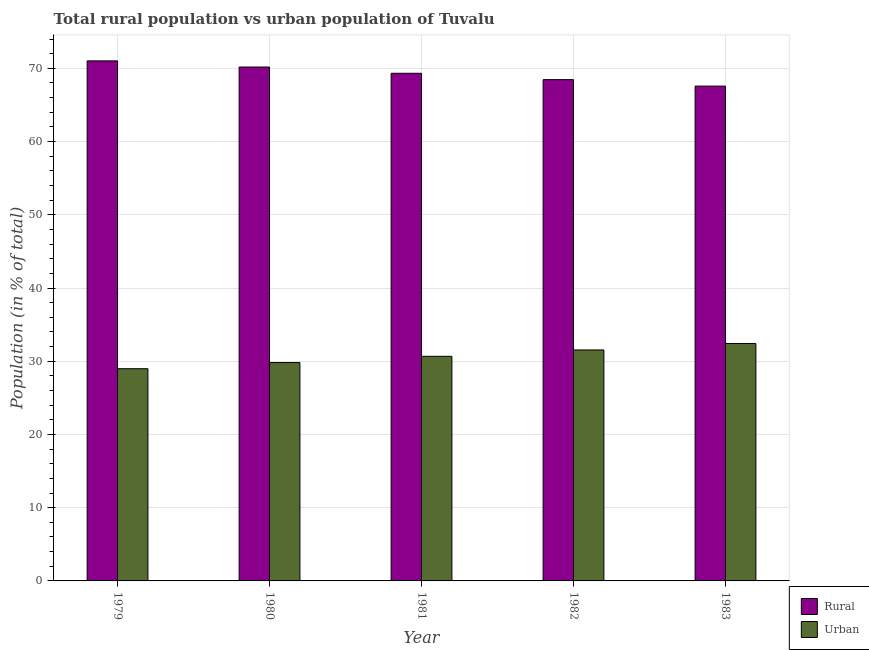How many different coloured bars are there?
Your response must be concise. 2. Are the number of bars on each tick of the X-axis equal?
Keep it short and to the point. Yes. How many bars are there on the 4th tick from the left?
Offer a very short reply. 2. In how many cases, is the number of bars for a given year not equal to the number of legend labels?
Keep it short and to the point. 0. What is the rural population in 1979?
Provide a short and direct response. 71.02. Across all years, what is the maximum rural population?
Make the answer very short. 71.02. Across all years, what is the minimum rural population?
Offer a very short reply. 67.58. In which year was the rural population maximum?
Your response must be concise. 1979. In which year was the urban population minimum?
Give a very brief answer. 1979. What is the total rural population in the graph?
Offer a very short reply. 346.55. What is the difference between the urban population in 1981 and that in 1983?
Your answer should be compact. -1.75. What is the difference between the rural population in 1979 and the urban population in 1982?
Provide a succinct answer. 2.56. What is the average rural population per year?
Make the answer very short. 69.31. In the year 1980, what is the difference between the urban population and rural population?
Make the answer very short. 0. What is the ratio of the rural population in 1981 to that in 1983?
Offer a very short reply. 1.03. Is the urban population in 1980 less than that in 1981?
Offer a very short reply. Yes. What is the difference between the highest and the second highest urban population?
Ensure brevity in your answer.  0.88. What is the difference between the highest and the lowest urban population?
Your response must be concise. 3.44. Is the sum of the urban population in 1980 and 1982 greater than the maximum rural population across all years?
Your answer should be compact. Yes. What does the 2nd bar from the left in 1979 represents?
Keep it short and to the point. Urban. What does the 2nd bar from the right in 1979 represents?
Offer a terse response. Rural. How many bars are there?
Provide a short and direct response. 10. What is the difference between two consecutive major ticks on the Y-axis?
Offer a terse response. 10. Are the values on the major ticks of Y-axis written in scientific E-notation?
Offer a terse response. No. Does the graph contain any zero values?
Your answer should be compact. No. Does the graph contain grids?
Keep it short and to the point. Yes. Where does the legend appear in the graph?
Ensure brevity in your answer.  Bottom right. How many legend labels are there?
Provide a short and direct response. 2. How are the legend labels stacked?
Your answer should be very brief. Vertical. What is the title of the graph?
Your answer should be very brief. Total rural population vs urban population of Tuvalu. What is the label or title of the X-axis?
Your response must be concise. Year. What is the label or title of the Y-axis?
Make the answer very short. Population (in % of total). What is the Population (in % of total) in Rural in 1979?
Your answer should be very brief. 71.02. What is the Population (in % of total) of Urban in 1979?
Ensure brevity in your answer.  28.98. What is the Population (in % of total) in Rural in 1980?
Provide a succinct answer. 70.18. What is the Population (in % of total) of Urban in 1980?
Offer a very short reply. 29.82. What is the Population (in % of total) of Rural in 1981?
Make the answer very short. 69.33. What is the Population (in % of total) of Urban in 1981?
Your response must be concise. 30.68. What is the Population (in % of total) of Rural in 1982?
Make the answer very short. 68.46. What is the Population (in % of total) of Urban in 1982?
Provide a short and direct response. 31.54. What is the Population (in % of total) of Rural in 1983?
Make the answer very short. 67.58. What is the Population (in % of total) of Urban in 1983?
Offer a terse response. 32.42. Across all years, what is the maximum Population (in % of total) in Rural?
Make the answer very short. 71.02. Across all years, what is the maximum Population (in % of total) of Urban?
Provide a succinct answer. 32.42. Across all years, what is the minimum Population (in % of total) in Rural?
Your answer should be compact. 67.58. Across all years, what is the minimum Population (in % of total) of Urban?
Your answer should be very brief. 28.98. What is the total Population (in % of total) of Rural in the graph?
Offer a very short reply. 346.55. What is the total Population (in % of total) of Urban in the graph?
Provide a succinct answer. 153.45. What is the difference between the Population (in % of total) of Rural in 1979 and that in 1980?
Provide a short and direct response. 0.84. What is the difference between the Population (in % of total) of Urban in 1979 and that in 1980?
Offer a terse response. -0.84. What is the difference between the Population (in % of total) in Rural in 1979 and that in 1981?
Give a very brief answer. 1.7. What is the difference between the Population (in % of total) of Urban in 1979 and that in 1981?
Keep it short and to the point. -1.7. What is the difference between the Population (in % of total) of Rural in 1979 and that in 1982?
Keep it short and to the point. 2.56. What is the difference between the Population (in % of total) of Urban in 1979 and that in 1982?
Give a very brief answer. -2.56. What is the difference between the Population (in % of total) of Rural in 1979 and that in 1983?
Make the answer very short. 3.44. What is the difference between the Population (in % of total) in Urban in 1979 and that in 1983?
Your answer should be compact. -3.44. What is the difference between the Population (in % of total) in Rural in 1980 and that in 1981?
Keep it short and to the point. 0.85. What is the difference between the Population (in % of total) of Urban in 1980 and that in 1981?
Your answer should be very brief. -0.85. What is the difference between the Population (in % of total) in Rural in 1980 and that in 1982?
Offer a very short reply. 1.72. What is the difference between the Population (in % of total) in Urban in 1980 and that in 1982?
Offer a terse response. -1.72. What is the difference between the Population (in % of total) in Rural in 1980 and that in 1983?
Offer a terse response. 2.6. What is the difference between the Population (in % of total) in Urban in 1980 and that in 1983?
Give a very brief answer. -2.6. What is the difference between the Population (in % of total) in Rural in 1981 and that in 1982?
Provide a short and direct response. 0.87. What is the difference between the Population (in % of total) in Urban in 1981 and that in 1982?
Your answer should be compact. -0.87. What is the difference between the Population (in % of total) in Rural in 1981 and that in 1983?
Give a very brief answer. 1.75. What is the difference between the Population (in % of total) of Urban in 1981 and that in 1983?
Ensure brevity in your answer.  -1.75. What is the difference between the Population (in % of total) of Rural in 1982 and that in 1983?
Offer a very short reply. 0.88. What is the difference between the Population (in % of total) in Urban in 1982 and that in 1983?
Your answer should be compact. -0.88. What is the difference between the Population (in % of total) in Rural in 1979 and the Population (in % of total) in Urban in 1980?
Your answer should be compact. 41.2. What is the difference between the Population (in % of total) of Rural in 1979 and the Population (in % of total) of Urban in 1981?
Your response must be concise. 40.34. What is the difference between the Population (in % of total) in Rural in 1979 and the Population (in % of total) in Urban in 1982?
Keep it short and to the point. 39.48. What is the difference between the Population (in % of total) in Rural in 1979 and the Population (in % of total) in Urban in 1983?
Your answer should be compact. 38.59. What is the difference between the Population (in % of total) of Rural in 1980 and the Population (in % of total) of Urban in 1981?
Keep it short and to the point. 39.5. What is the difference between the Population (in % of total) of Rural in 1980 and the Population (in % of total) of Urban in 1982?
Offer a terse response. 38.63. What is the difference between the Population (in % of total) in Rural in 1980 and the Population (in % of total) in Urban in 1983?
Offer a terse response. 37.75. What is the difference between the Population (in % of total) of Rural in 1981 and the Population (in % of total) of Urban in 1982?
Your response must be concise. 37.78. What is the difference between the Population (in % of total) in Rural in 1981 and the Population (in % of total) in Urban in 1983?
Offer a very short reply. 36.9. What is the difference between the Population (in % of total) in Rural in 1982 and the Population (in % of total) in Urban in 1983?
Keep it short and to the point. 36.03. What is the average Population (in % of total) in Rural per year?
Provide a short and direct response. 69.31. What is the average Population (in % of total) of Urban per year?
Your response must be concise. 30.69. In the year 1979, what is the difference between the Population (in % of total) of Rural and Population (in % of total) of Urban?
Offer a very short reply. 42.04. In the year 1980, what is the difference between the Population (in % of total) in Rural and Population (in % of total) in Urban?
Provide a succinct answer. 40.36. In the year 1981, what is the difference between the Population (in % of total) in Rural and Population (in % of total) in Urban?
Keep it short and to the point. 38.65. In the year 1982, what is the difference between the Population (in % of total) of Rural and Population (in % of total) of Urban?
Provide a short and direct response. 36.91. In the year 1983, what is the difference between the Population (in % of total) in Rural and Population (in % of total) in Urban?
Provide a succinct answer. 35.15. What is the ratio of the Population (in % of total) of Urban in 1979 to that in 1980?
Your answer should be compact. 0.97. What is the ratio of the Population (in % of total) in Rural in 1979 to that in 1981?
Your answer should be compact. 1.02. What is the ratio of the Population (in % of total) in Urban in 1979 to that in 1981?
Offer a terse response. 0.94. What is the ratio of the Population (in % of total) in Rural in 1979 to that in 1982?
Your response must be concise. 1.04. What is the ratio of the Population (in % of total) of Urban in 1979 to that in 1982?
Your response must be concise. 0.92. What is the ratio of the Population (in % of total) of Rural in 1979 to that in 1983?
Your answer should be compact. 1.05. What is the ratio of the Population (in % of total) in Urban in 1979 to that in 1983?
Make the answer very short. 0.89. What is the ratio of the Population (in % of total) in Rural in 1980 to that in 1981?
Your answer should be compact. 1.01. What is the ratio of the Population (in % of total) of Urban in 1980 to that in 1981?
Make the answer very short. 0.97. What is the ratio of the Population (in % of total) in Rural in 1980 to that in 1982?
Your answer should be very brief. 1.03. What is the ratio of the Population (in % of total) in Urban in 1980 to that in 1982?
Ensure brevity in your answer.  0.95. What is the ratio of the Population (in % of total) of Urban in 1980 to that in 1983?
Provide a short and direct response. 0.92. What is the ratio of the Population (in % of total) in Rural in 1981 to that in 1982?
Make the answer very short. 1.01. What is the ratio of the Population (in % of total) in Urban in 1981 to that in 1982?
Offer a very short reply. 0.97. What is the ratio of the Population (in % of total) of Rural in 1981 to that in 1983?
Give a very brief answer. 1.03. What is the ratio of the Population (in % of total) of Urban in 1981 to that in 1983?
Offer a very short reply. 0.95. What is the ratio of the Population (in % of total) of Urban in 1982 to that in 1983?
Provide a succinct answer. 0.97. What is the difference between the highest and the second highest Population (in % of total) in Rural?
Your response must be concise. 0.84. What is the difference between the highest and the second highest Population (in % of total) of Urban?
Offer a very short reply. 0.88. What is the difference between the highest and the lowest Population (in % of total) in Rural?
Your answer should be very brief. 3.44. What is the difference between the highest and the lowest Population (in % of total) in Urban?
Offer a terse response. 3.44. 